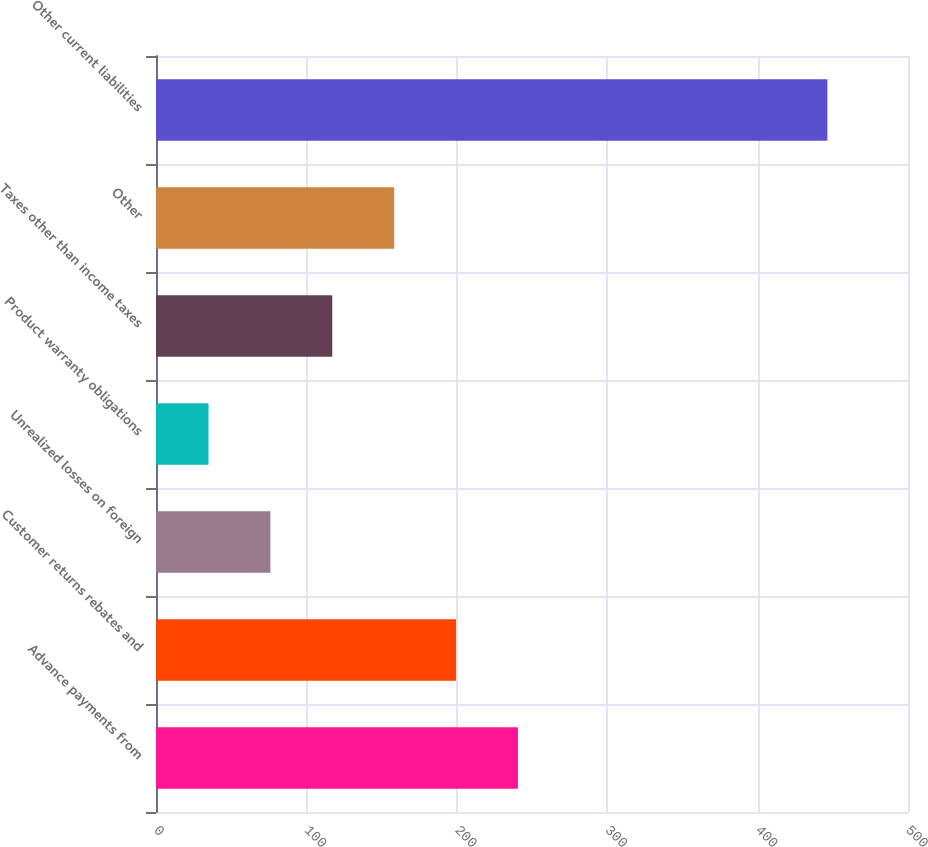Convert chart. <chart><loc_0><loc_0><loc_500><loc_500><bar_chart><fcel>Advance payments from<fcel>Customer returns rebates and<fcel>Unrealized losses on foreign<fcel>Product warranty obligations<fcel>Taxes other than income taxes<fcel>Other<fcel>Other current liabilities<nl><fcel>240.65<fcel>199.5<fcel>76.05<fcel>34.9<fcel>117.2<fcel>158.35<fcel>446.4<nl></chart> 